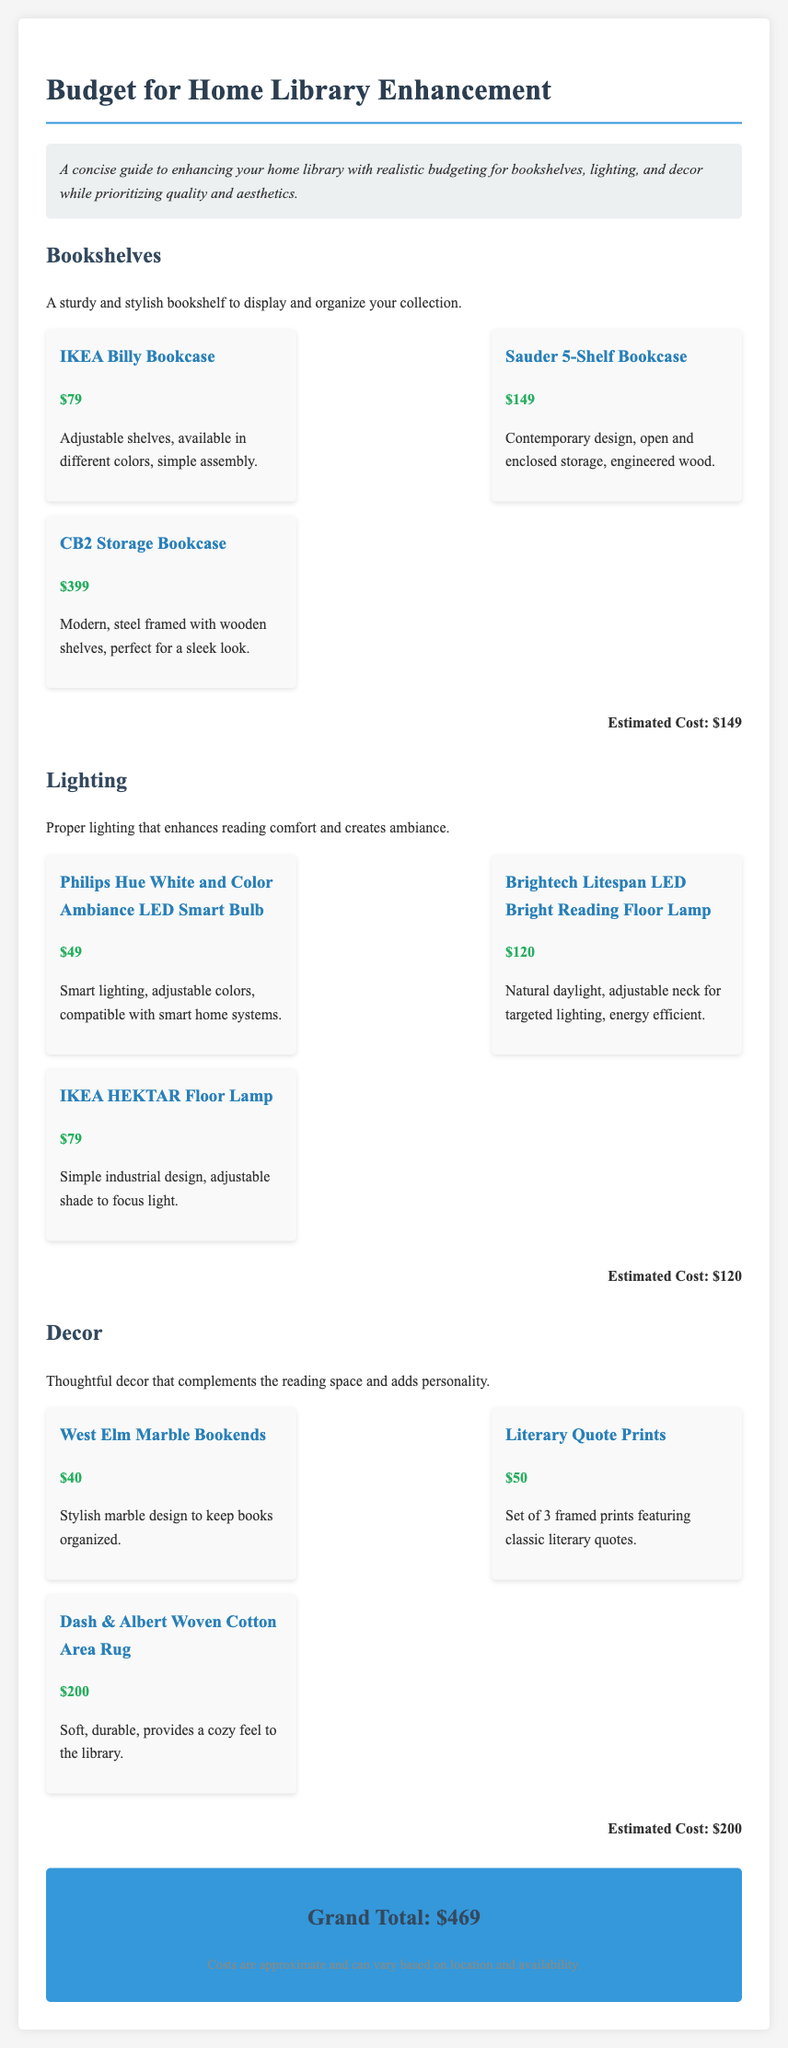What is the estimated cost for bookshelves? The estimated cost for bookshelves is detailed in the document under that category, which states $149.
Answer: $149 How much does the IKEA HEKTAR Floor Lamp cost? The IKEA HEKTAR Floor Lamp's cost is provided in the lighting section of the document, listed as $79.
Answer: $79 What is the total estimated cost for decor? The document summarizes the estimated cost for decor, which amounts to $200.
Answer: $200 Which bookshelf option has the highest price? By reviewing the options listed for bookshelves, the CB2 Storage Bookcase is listed as the most expensive at $399.
Answer: $399 What lighting option is described as energy efficient? The Brightech Litespan LED Bright Reading Floor Lamp is specifically labeled as energy efficient in the lighting section.
Answer: Brightech Litespan LED Bright Reading Floor Lamp What is the grand total for all categories? The document clearly states the grand total at the bottom, which is $469.
Answer: $469 Which decor item has a stylish design feature? The West Elm Marble Bookends are noted for their stylish marble design in the decor section.
Answer: West Elm Marble Bookends How many options are listed in the lighting category? The lighting category contains three specified options, as shown in the document.
Answer: 3 What is the price of the Literary Quote Prints? The document indicates that the Literary Quote Prints are priced at $50.
Answer: $50 